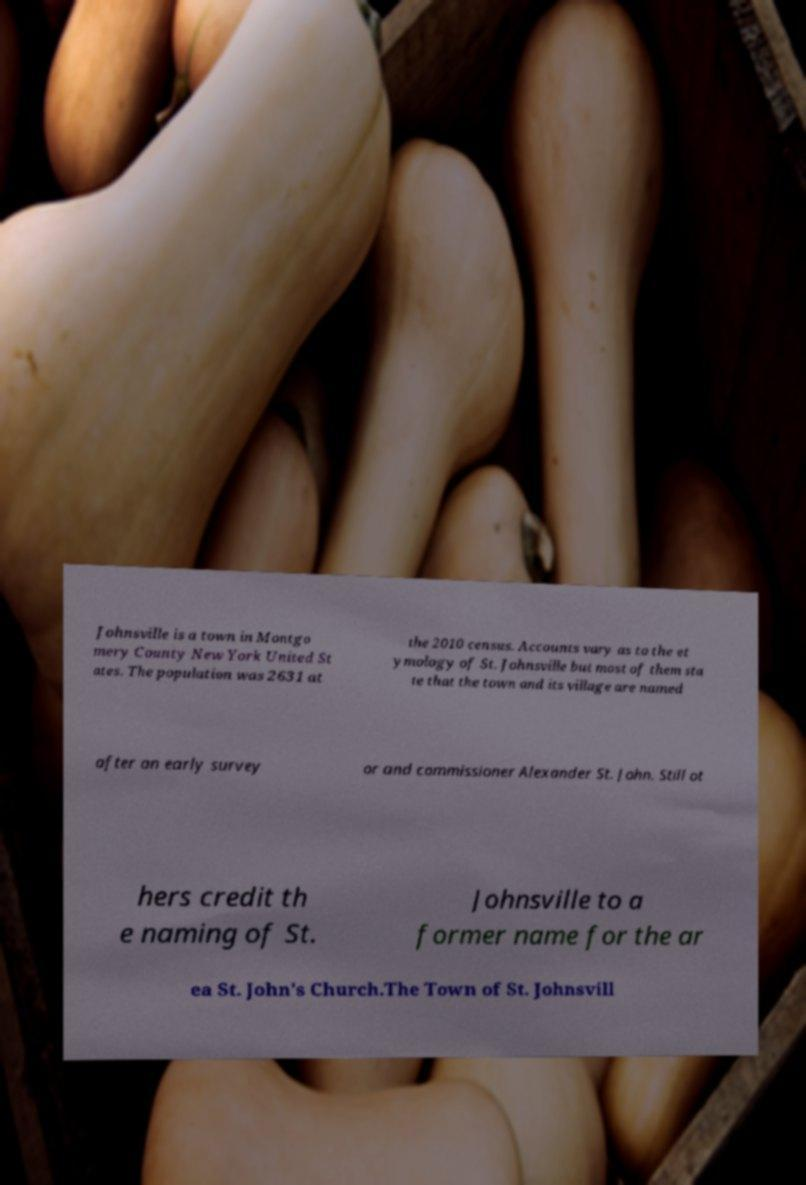What messages or text are displayed in this image? I need them in a readable, typed format. Johnsville is a town in Montgo mery County New York United St ates. The population was 2631 at the 2010 census. Accounts vary as to the et ymology of St. Johnsville but most of them sta te that the town and its village are named after an early survey or and commissioner Alexander St. John. Still ot hers credit th e naming of St. Johnsville to a former name for the ar ea St. John's Church.The Town of St. Johnsvill 